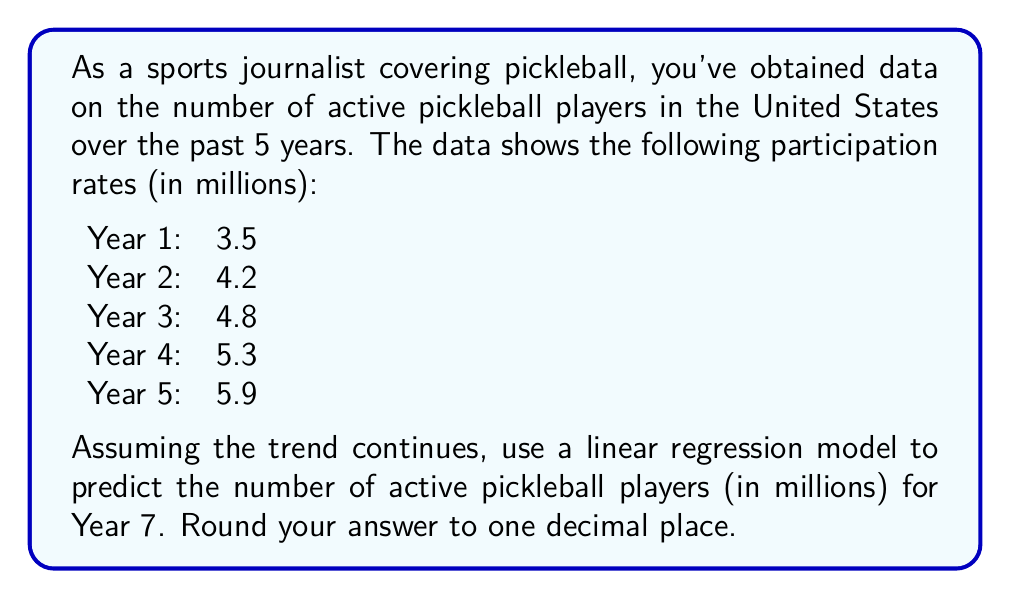Provide a solution to this math problem. To solve this problem, we'll use a linear regression model to analyze the trend and make a prediction. Here are the steps:

1. Define variables:
   Let $x$ represent the year (1 to 5)
   Let $y$ represent the number of active players (in millions)

2. Calculate the means:
   $\bar{x} = \frac{1 + 2 + 3 + 4 + 5}{5} = 3$
   $\bar{y} = \frac{3.5 + 4.2 + 4.8 + 5.3 + 5.9}{5} = 4.74$

3. Calculate the slope ($m$) of the regression line:
   $m = \frac{\sum(x_i - \bar{x})(y_i - \bar{y})}{\sum(x_i - \bar{x})^2}$

   $\sum(x_i - \bar{x})(y_i - \bar{y}) = (-2)(-1.24) + (-1)(-0.54) + (0)(0.06) + (1)(0.56) + (2)(1.16) = 4.88$
   $\sum(x_i - \bar{x})^2 = (-2)^2 + (-1)^2 + (0)^2 + (1)^2 + (2)^2 = 10$

   $m = \frac{4.88}{10} = 0.488$

4. Calculate the y-intercept ($b$) using the point-slope form:
   $b = \bar{y} - m\bar{x} = 4.74 - (0.488)(3) = 3.276$

5. The linear regression equation is:
   $y = 0.488x + 3.276$

6. To predict Year 7, substitute $x = 7$:
   $y = 0.488(7) + 3.276 = 6.692$

7. Round to one decimal place: 6.7
Answer: 6.7 million active pickleball players 